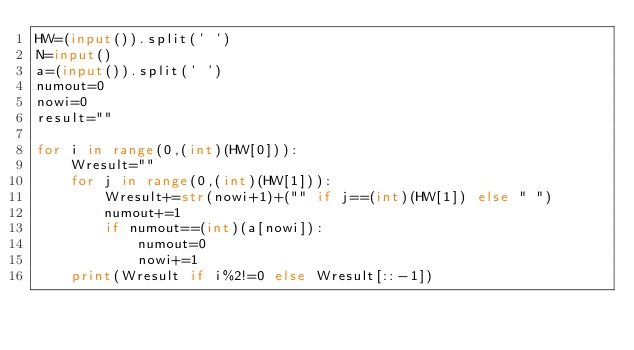<code> <loc_0><loc_0><loc_500><loc_500><_Python_>HW=(input()).split(' ')
N=input()
a=(input()).split(' ')
numout=0
nowi=0
result=""

for i in range(0,(int)(HW[0])):
    Wresult=""
    for j in range(0,(int)(HW[1])):
        Wresult+=str(nowi+1)+("" if j==(int)(HW[1]) else " ")
        numout+=1
        if numout==(int)(a[nowi]):
            numout=0
            nowi+=1
    print(Wresult if i%2!=0 else Wresult[::-1])</code> 